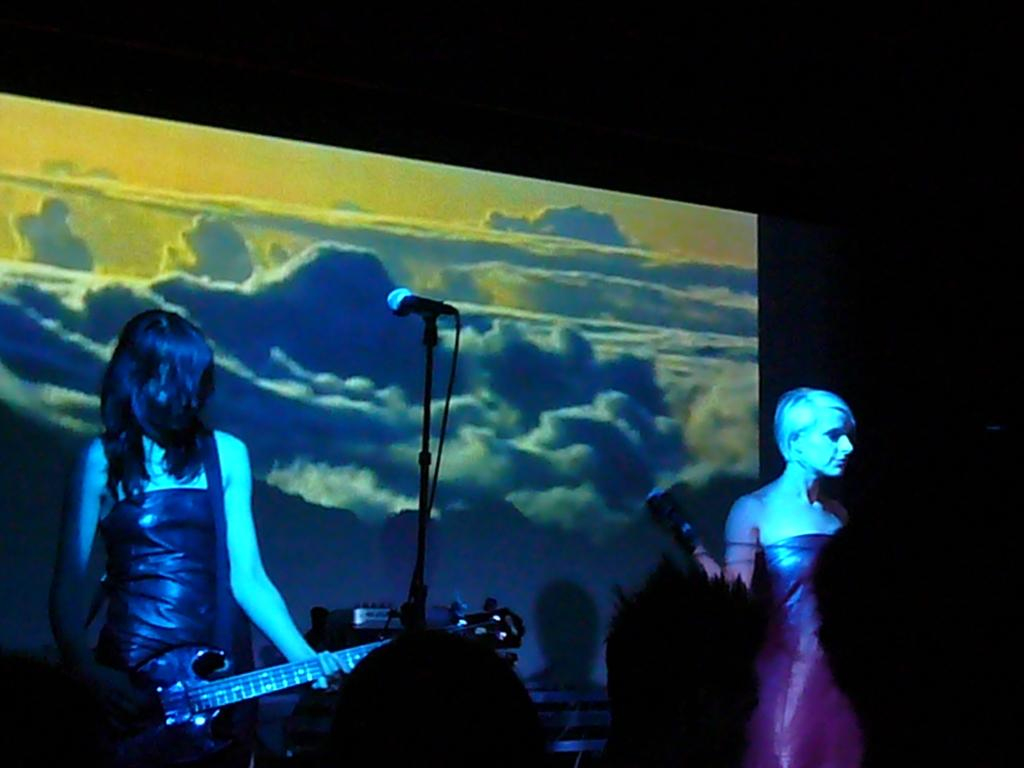How many women are in the image? There are two women in the image. What is one of the women holding? One of the women is holding a guitar. What equipment is present for amplifying sound in the image? There is a microphone and a microphone stand in the image. What can be seen in the background of the image? The sky is visible in the image, and it appears to be cloudy. What type of arch can be seen in the image? There is no arch present in the image. What knowledge is being shared between the two women in the image? The image does not provide any information about the exchange of knowledge between the two women. 